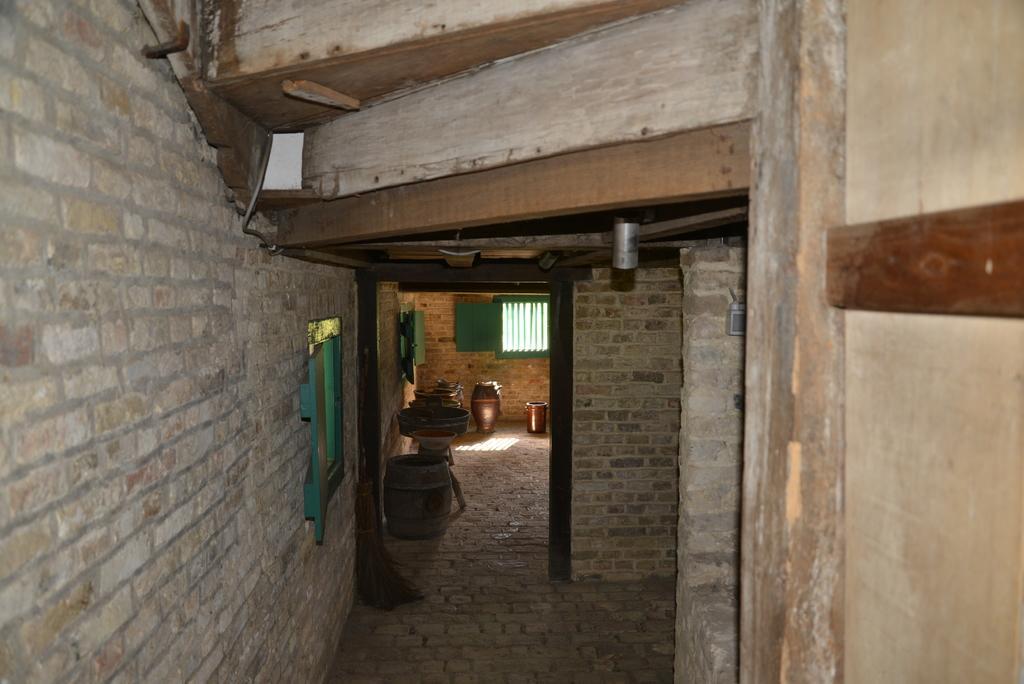How would you summarize this image in a sentence or two? This is the picture of a room. At the back there is a broom and there is a drum and there are objects and there are windows. In the foreground on the right side of the image there is a door. On the left side of the image there is a wall. At the bottom there is a floor and there is a sun light on the floor. 